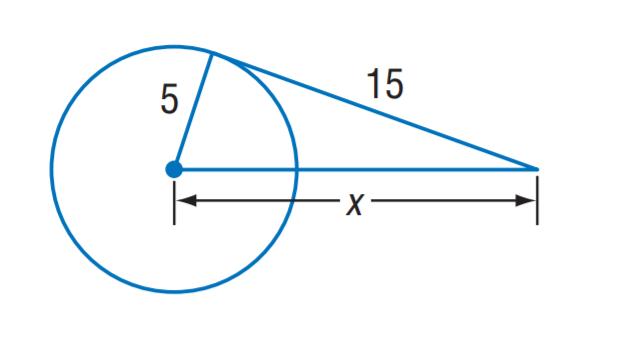Question: The segment is tangent to the circle. Find x.
Choices:
A. 5 \sqrt { 5 }
B. 5 \sqrt { 10 }
C. 10 \sqrt { 5 }
D. 10 \sqrt { 10 }
Answer with the letter. Answer: B 